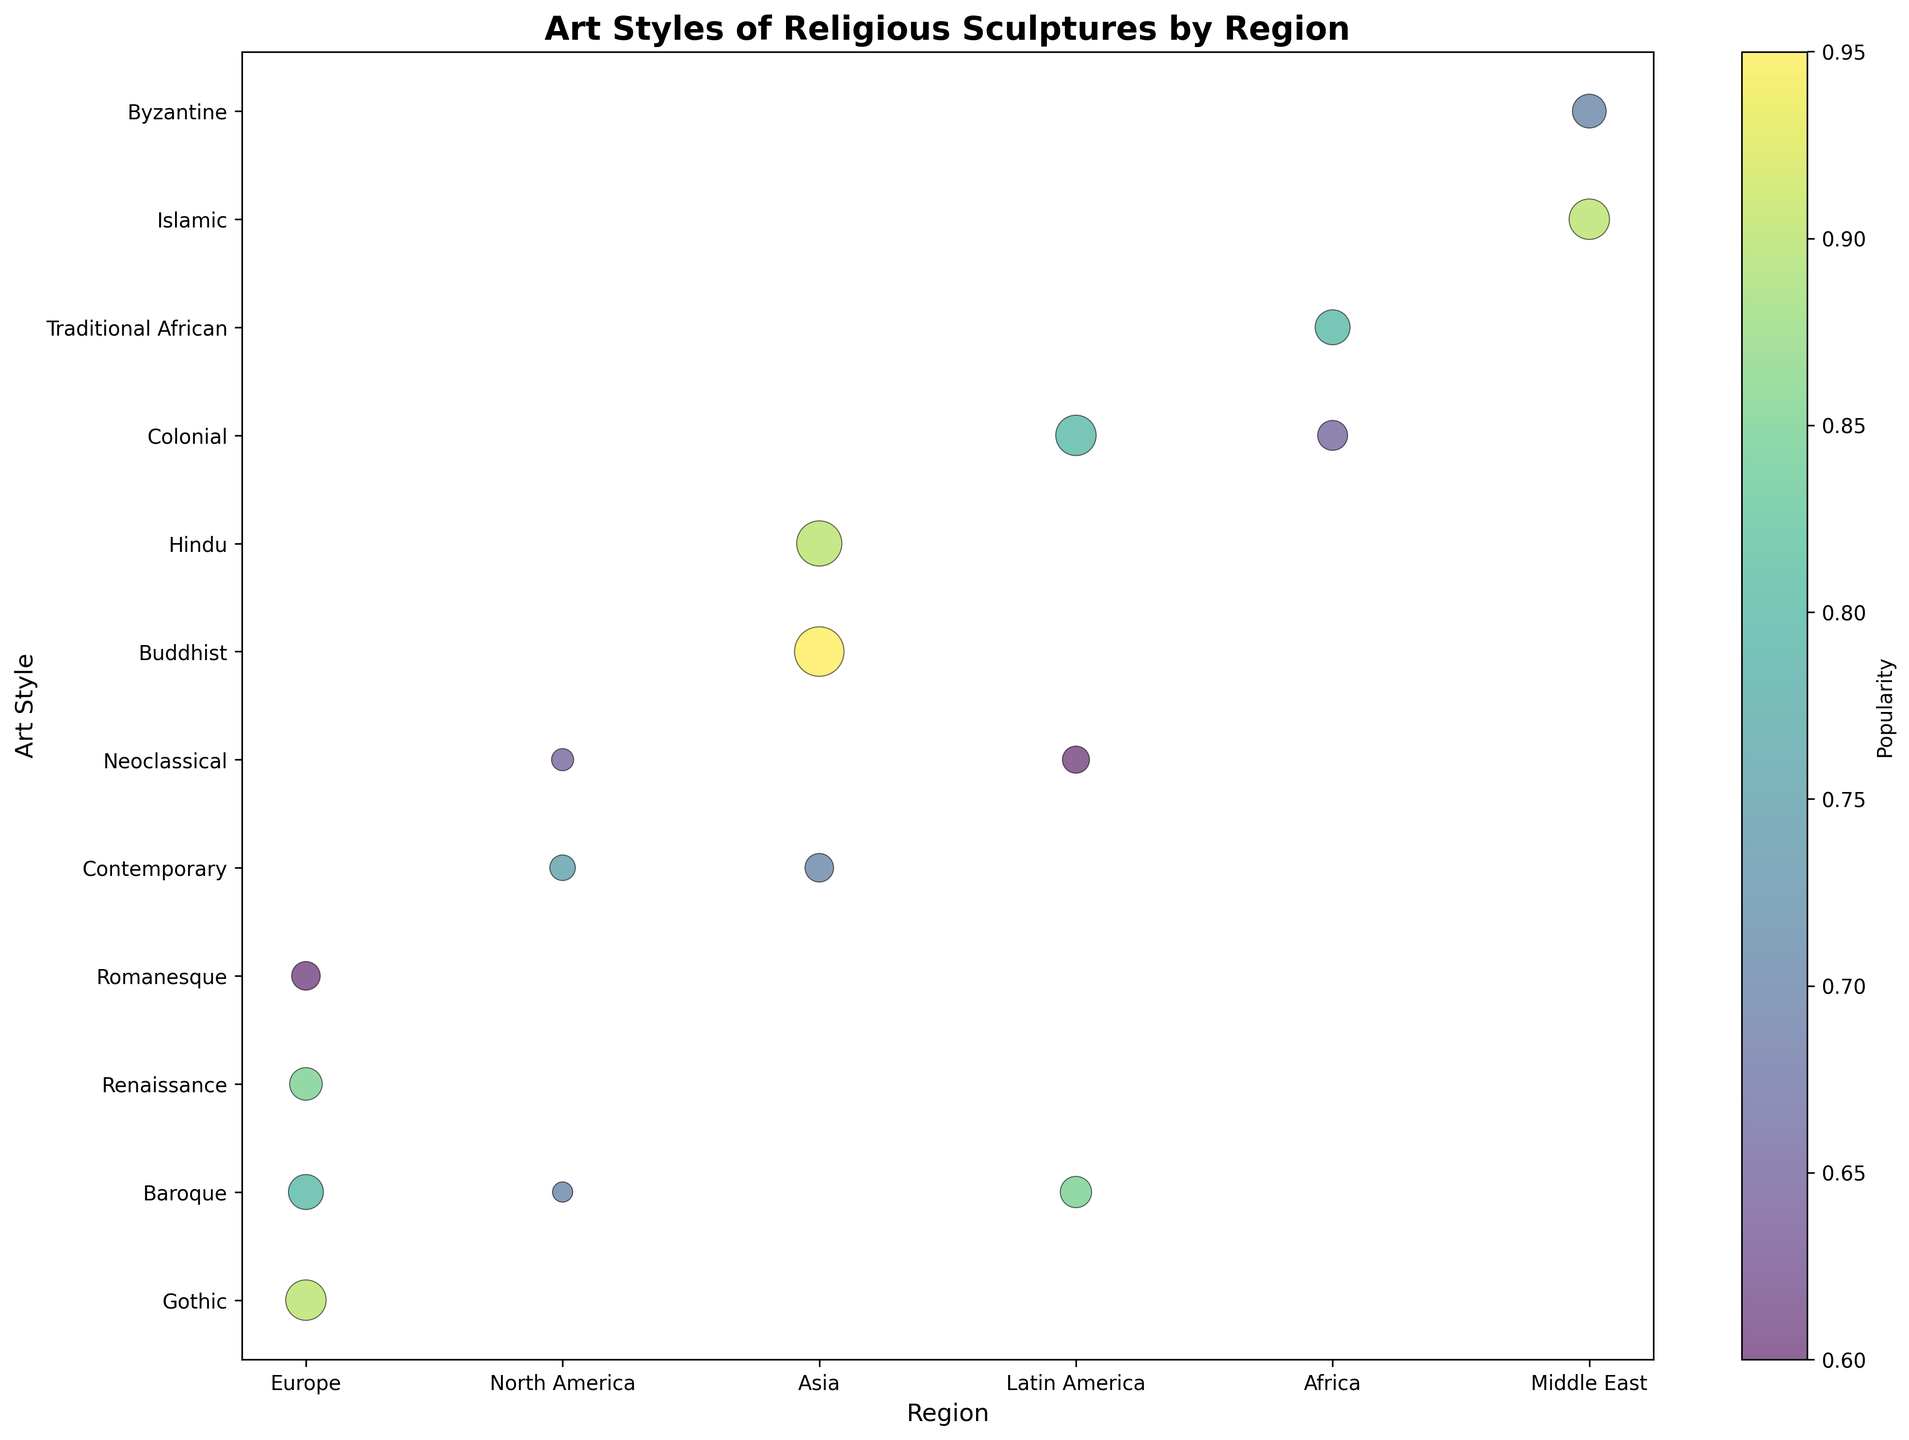What region has the largest number of Gothic sculptures? Look for the bubble corresponding to Gothic sculptures and check its region. The bubble for Gothic sculptures is located in Europe.
Answer: Europe Which art style is the most popular in Asia? Look for bubbles in the Asia region and identify the one with the highest color intensity on the color scale. The Buddhist art style has the highest intensity, indicating the highest popularity.
Answer: Buddhist Compare the popularity of Baroque sculptures in Europe and North America. Which is higher? Locate the Baroque bubbles in both Europe and North America and compare their color intensities using the color bar. Europe's Baroque bubble has a higher popularity.
Answer: Europe How many more Renaissance sculptures are there in Europe compared to Neoclassical sculptures in North America? Identify the bubbles for Renaissance in Europe and Neoclassical in North America. Renaissance has 130 sculptures, and Neoclassical has 60. The difference is 130 - 60 = 70.
Answer: 70 What is the average popularity of all art styles in Latin America? Identify the Latin American art styles and their popularities: Baroque (0.85), Colonial (0.8), Neoclassical (0.6). Calculate the average: (0.85 + 0.8 + 0.6) / 3 = 2.25 / 3 ≈ 0.75.
Answer: 0.75 Which region shows the highest diversity in art styles presented in the chart? Count the number of distinct art style bubbles per region. Asia has Buddhist, Hindu, and Contemporary, totaling 3 distinct styles.
Answer: Asia Which region has the highest number of sculptures overall? Sum the number of sculptures for all art styles in each region. Asia has the highest total: Buddhist (300) + Hindu (250) + Contemporary (100) = 650 sculptures.
Answer: Asia Is the Colonial art style more popular in Latin America or Africa? Compare the color intensities of the Colonial bubbles in both regions using the color bar. Latin America's Colonial bubble has higher intensity, indicating greater popularity.
Answer: Latin America How many art styles in Europe have a popularity above 0.75? Identify European art style bubbles with popularity > 0.75: Gothic (0.9), Baroque (0.8), Renaissance (0.85). Count them, which gives 3 styles.
Answer: 3 Which art style in the Middle East has the lowest popularity? Identify the art styles in the Middle East and their popularities: Islamic (0.9) and Byzantine (0.7). The Byzantine style has the lower popularity.
Answer: Byzantine 